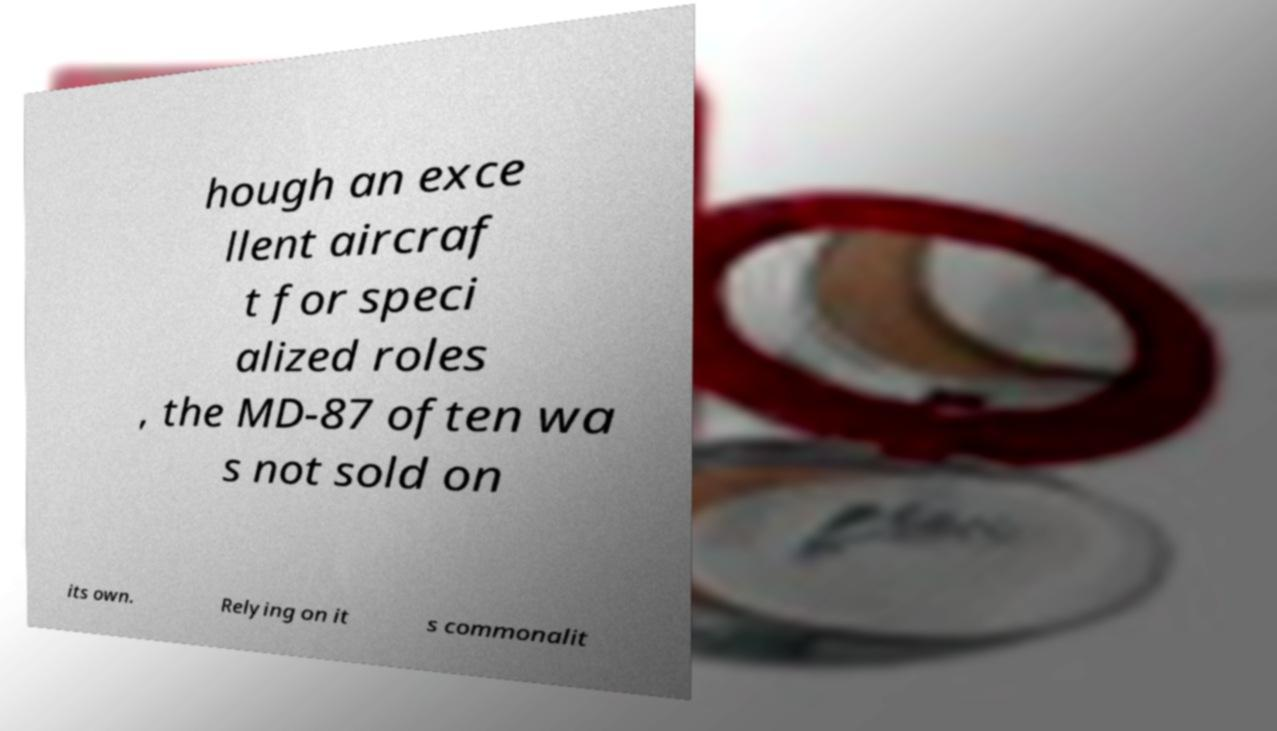There's text embedded in this image that I need extracted. Can you transcribe it verbatim? hough an exce llent aircraf t for speci alized roles , the MD-87 often wa s not sold on its own. Relying on it s commonalit 